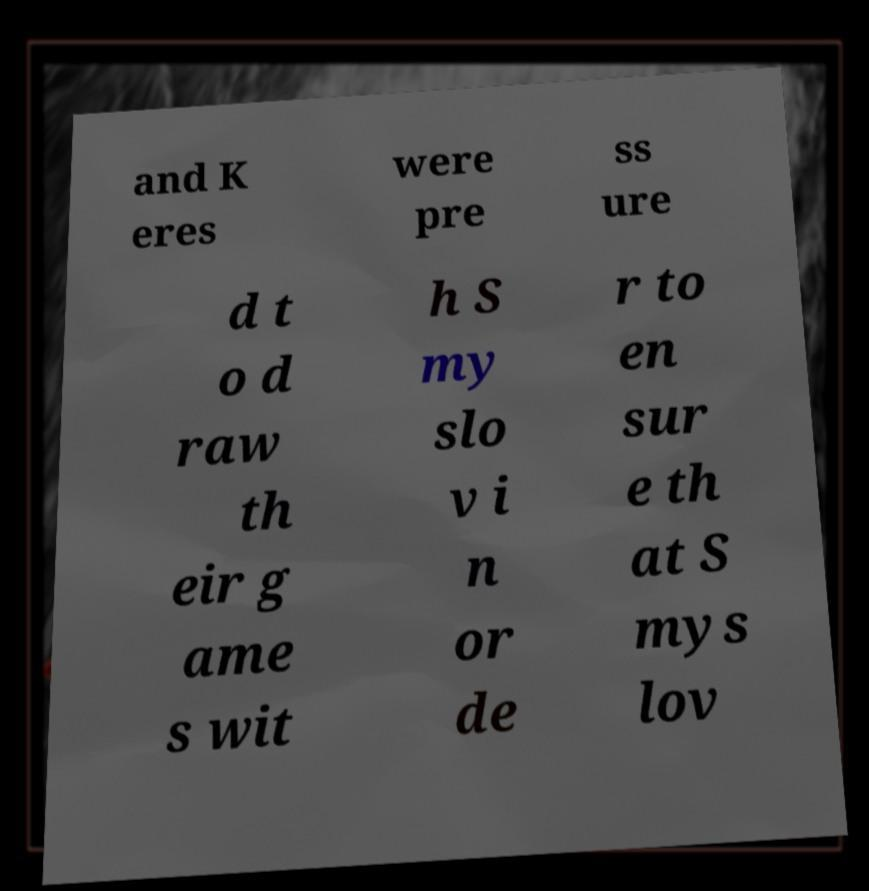Can you accurately transcribe the text from the provided image for me? and K eres were pre ss ure d t o d raw th eir g ame s wit h S my slo v i n or de r to en sur e th at S mys lov 